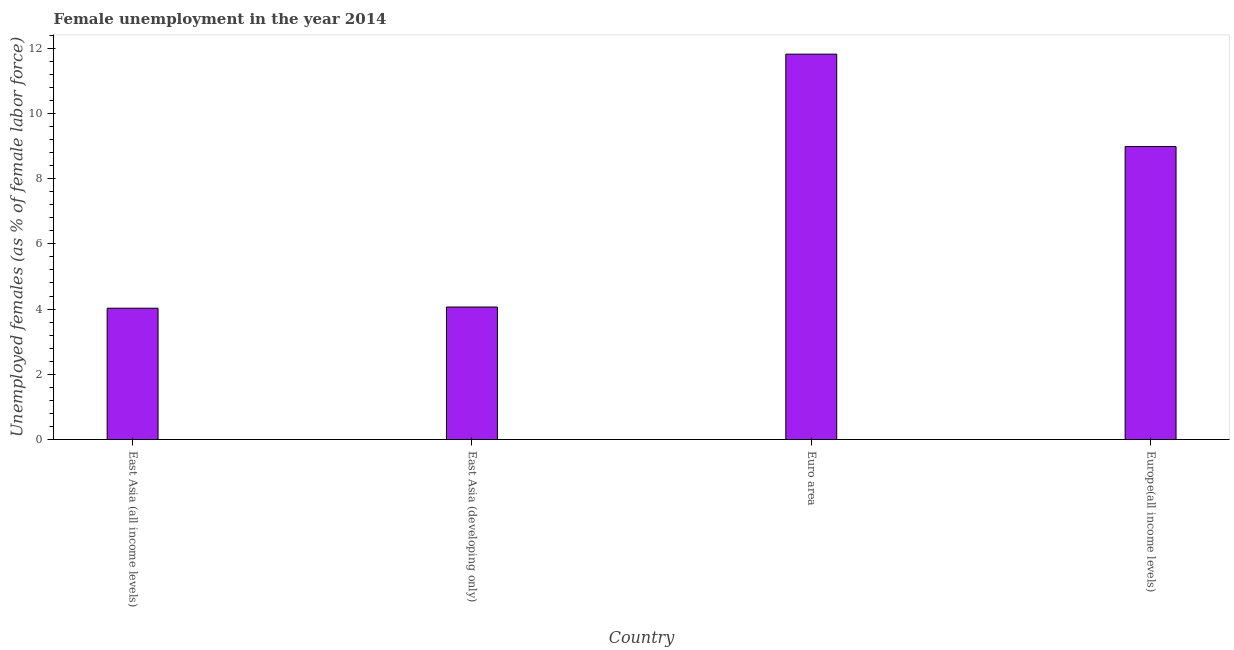Does the graph contain grids?
Ensure brevity in your answer.  No. What is the title of the graph?
Ensure brevity in your answer.  Female unemployment in the year 2014. What is the label or title of the Y-axis?
Your answer should be compact. Unemployed females (as % of female labor force). What is the unemployed females population in East Asia (developing only)?
Your response must be concise. 4.06. Across all countries, what is the maximum unemployed females population?
Provide a short and direct response. 11.82. Across all countries, what is the minimum unemployed females population?
Provide a succinct answer. 4.03. In which country was the unemployed females population minimum?
Ensure brevity in your answer.  East Asia (all income levels). What is the sum of the unemployed females population?
Provide a succinct answer. 28.89. What is the difference between the unemployed females population in Euro area and Europe(all income levels)?
Make the answer very short. 2.83. What is the average unemployed females population per country?
Keep it short and to the point. 7.22. What is the median unemployed females population?
Your answer should be very brief. 6.52. What is the ratio of the unemployed females population in Euro area to that in Europe(all income levels)?
Provide a succinct answer. 1.31. Is the unemployed females population in East Asia (all income levels) less than that in Euro area?
Provide a short and direct response. Yes. What is the difference between the highest and the second highest unemployed females population?
Ensure brevity in your answer.  2.83. Is the sum of the unemployed females population in East Asia (developing only) and Europe(all income levels) greater than the maximum unemployed females population across all countries?
Your answer should be compact. Yes. What is the difference between the highest and the lowest unemployed females population?
Your answer should be compact. 7.79. How many bars are there?
Offer a very short reply. 4. Are all the bars in the graph horizontal?
Provide a succinct answer. No. What is the difference between two consecutive major ticks on the Y-axis?
Keep it short and to the point. 2. Are the values on the major ticks of Y-axis written in scientific E-notation?
Ensure brevity in your answer.  No. What is the Unemployed females (as % of female labor force) in East Asia (all income levels)?
Provide a succinct answer. 4.03. What is the Unemployed females (as % of female labor force) of East Asia (developing only)?
Ensure brevity in your answer.  4.06. What is the Unemployed females (as % of female labor force) in Euro area?
Provide a succinct answer. 11.82. What is the Unemployed females (as % of female labor force) of Europe(all income levels)?
Give a very brief answer. 8.98. What is the difference between the Unemployed females (as % of female labor force) in East Asia (all income levels) and East Asia (developing only)?
Keep it short and to the point. -0.04. What is the difference between the Unemployed females (as % of female labor force) in East Asia (all income levels) and Euro area?
Make the answer very short. -7.79. What is the difference between the Unemployed females (as % of female labor force) in East Asia (all income levels) and Europe(all income levels)?
Give a very brief answer. -4.96. What is the difference between the Unemployed females (as % of female labor force) in East Asia (developing only) and Euro area?
Make the answer very short. -7.75. What is the difference between the Unemployed females (as % of female labor force) in East Asia (developing only) and Europe(all income levels)?
Provide a short and direct response. -4.92. What is the difference between the Unemployed females (as % of female labor force) in Euro area and Europe(all income levels)?
Offer a very short reply. 2.83. What is the ratio of the Unemployed females (as % of female labor force) in East Asia (all income levels) to that in Euro area?
Ensure brevity in your answer.  0.34. What is the ratio of the Unemployed females (as % of female labor force) in East Asia (all income levels) to that in Europe(all income levels)?
Your answer should be very brief. 0.45. What is the ratio of the Unemployed females (as % of female labor force) in East Asia (developing only) to that in Euro area?
Offer a terse response. 0.34. What is the ratio of the Unemployed females (as % of female labor force) in East Asia (developing only) to that in Europe(all income levels)?
Make the answer very short. 0.45. What is the ratio of the Unemployed females (as % of female labor force) in Euro area to that in Europe(all income levels)?
Offer a terse response. 1.31. 